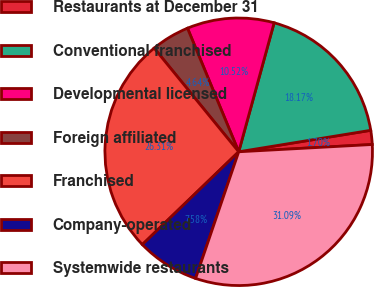Convert chart to OTSL. <chart><loc_0><loc_0><loc_500><loc_500><pie_chart><fcel>Restaurants at December 31<fcel>Conventional franchised<fcel>Developmental licensed<fcel>Foreign affiliated<fcel>Franchised<fcel>Company-operated<fcel>Systemwide restaurants<nl><fcel>1.7%<fcel>18.17%<fcel>10.52%<fcel>4.64%<fcel>26.31%<fcel>7.58%<fcel>31.09%<nl></chart> 